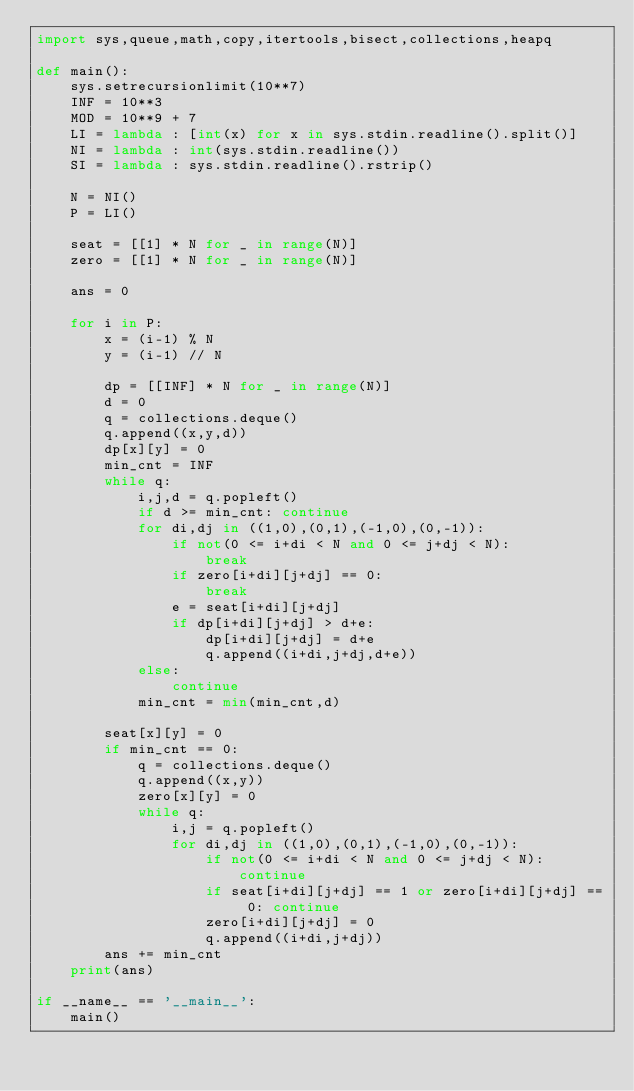<code> <loc_0><loc_0><loc_500><loc_500><_Python_>import sys,queue,math,copy,itertools,bisect,collections,heapq

def main():
    sys.setrecursionlimit(10**7)
    INF = 10**3
    MOD = 10**9 + 7
    LI = lambda : [int(x) for x in sys.stdin.readline().split()]
    NI = lambda : int(sys.stdin.readline())
    SI = lambda : sys.stdin.readline().rstrip()

    N = NI()
    P = LI()

    seat = [[1] * N for _ in range(N)]
    zero = [[1] * N for _ in range(N)]

    ans = 0

    for i in P:
        x = (i-1) % N
        y = (i-1) // N

        dp = [[INF] * N for _ in range(N)]
        d = 0
        q = collections.deque()
        q.append((x,y,d))
        dp[x][y] = 0
        min_cnt = INF
        while q:
            i,j,d = q.popleft()
            if d >= min_cnt: continue
            for di,dj in ((1,0),(0,1),(-1,0),(0,-1)):
                if not(0 <= i+di < N and 0 <= j+dj < N):
                    break
                if zero[i+di][j+dj] == 0:
                    break
                e = seat[i+di][j+dj]
                if dp[i+di][j+dj] > d+e:
                    dp[i+di][j+dj] = d+e
                    q.append((i+di,j+dj,d+e))
            else:
                continue
            min_cnt = min(min_cnt,d)

        seat[x][y] = 0
        if min_cnt == 0:
            q = collections.deque()
            q.append((x,y))
            zero[x][y] = 0
            while q:
                i,j = q.popleft()
                for di,dj in ((1,0),(0,1),(-1,0),(0,-1)):
                    if not(0 <= i+di < N and 0 <= j+dj < N): continue
                    if seat[i+di][j+dj] == 1 or zero[i+di][j+dj] == 0: continue
                    zero[i+di][j+dj] = 0
                    q.append((i+di,j+dj))
        ans += min_cnt
    print(ans)

if __name__ == '__main__':
    main()</code> 